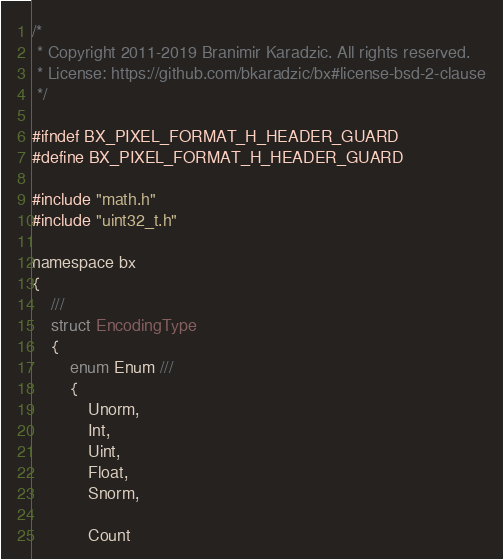Convert code to text. <code><loc_0><loc_0><loc_500><loc_500><_C_>/*
 * Copyright 2011-2019 Branimir Karadzic. All rights reserved.
 * License: https://github.com/bkaradzic/bx#license-bsd-2-clause
 */

#ifndef BX_PIXEL_FORMAT_H_HEADER_GUARD
#define BX_PIXEL_FORMAT_H_HEADER_GUARD

#include "math.h"
#include "uint32_t.h"

namespace bx
{
	///
	struct EncodingType
	{
		enum Enum ///
		{
			Unorm,
			Int,
			Uint,
			Float,
			Snorm,

			Count</code> 